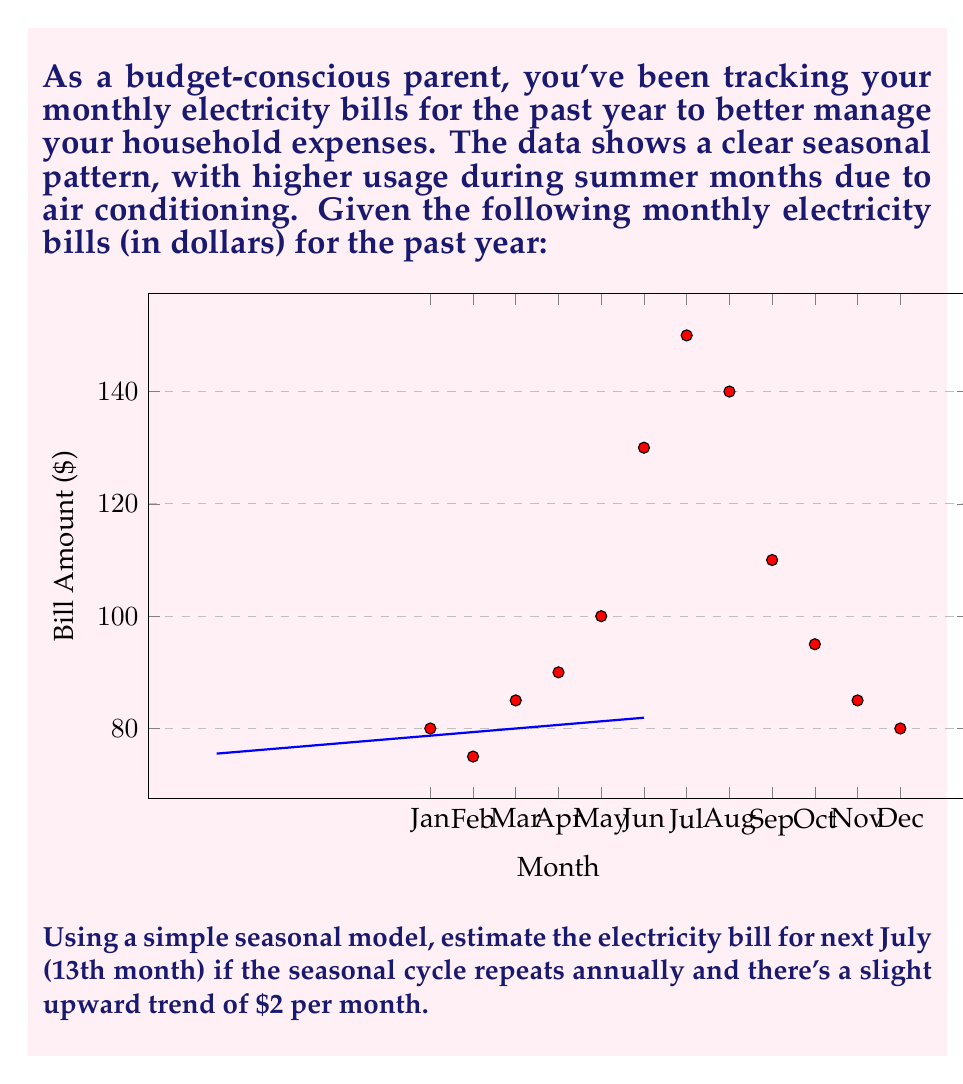Solve this math problem. Let's approach this step-by-step:

1) First, we need to identify the seasonal pattern. We can see that the peak occurs in July (7th month) with $150.

2) We can model this seasonal pattern using a sine function:

   $$f(t) = A \sin(\frac{2\pi}{12}(t-t_0)) + B$$

   Where $A$ is the amplitude, $t$ is the month number, $t_0$ is the phase shift, and $B$ is the vertical shift.

3) From the data, we can estimate:
   - Amplitude $A = \frac{150 - 80}{2} = 35$
   - Phase shift $t_0 = 2$ (peak is 2 months after midpoint between Jan and Jul)
   - Vertical shift $B = \frac{150 + 80}{2} = 115$

4) So our seasonal model is:

   $$f(t) = 35 \sin(\frac{2\pi}{12}(t-2)) + 115$$

5) Now, we need to add the upward trend of $2 per month:

   $$g(t) = 35 \sin(\frac{2\pi}{12}(t-2)) + 115 + 2t$$

6) For next July, $t = 13$ (13th month from start):

   $$g(13) = 35 \sin(\frac{2\pi}{12}(13-2)) + 115 + 2(13)$$
   $$= 35 \sin(\frac{11\pi}{6}) + 115 + 26$$
   $$\approx 35(0.966) + 115 + 26$$
   $$\approx 33.81 + 115 + 26$$
   $$\approx 174.81$$

7) Rounding to the nearest dollar (as bills are typically given):

   $$\text{Estimated bill} \approx \$175$$
Answer: $175 